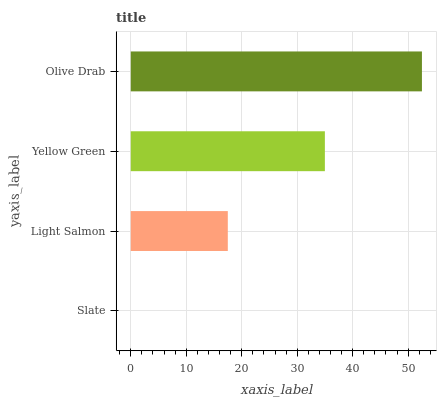Is Slate the minimum?
Answer yes or no. Yes. Is Olive Drab the maximum?
Answer yes or no. Yes. Is Light Salmon the minimum?
Answer yes or no. No. Is Light Salmon the maximum?
Answer yes or no. No. Is Light Salmon greater than Slate?
Answer yes or no. Yes. Is Slate less than Light Salmon?
Answer yes or no. Yes. Is Slate greater than Light Salmon?
Answer yes or no. No. Is Light Salmon less than Slate?
Answer yes or no. No. Is Yellow Green the high median?
Answer yes or no. Yes. Is Light Salmon the low median?
Answer yes or no. Yes. Is Light Salmon the high median?
Answer yes or no. No. Is Olive Drab the low median?
Answer yes or no. No. 